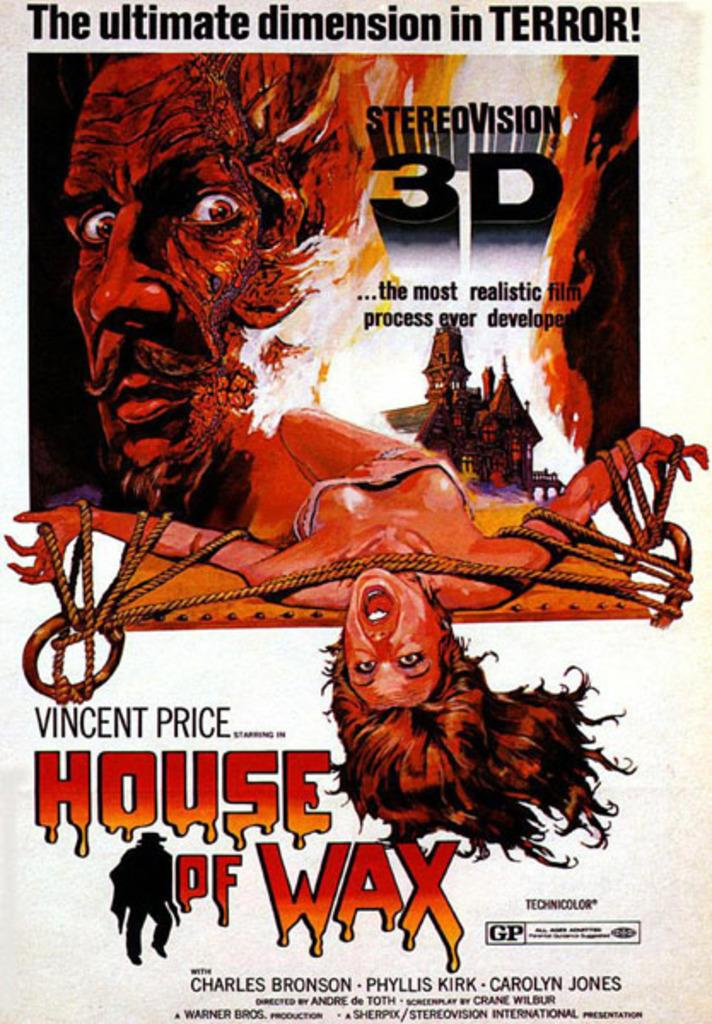<image>
Summarize the visual content of the image. Vincent Price is starring in the House of Wax a 3D film of terror. 